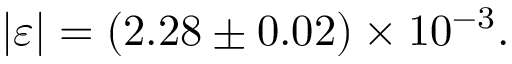Convert formula to latex. <formula><loc_0><loc_0><loc_500><loc_500>| \varepsilon | = ( 2 . 2 8 \pm 0 . 0 2 ) \times 1 0 ^ { - 3 } .</formula> 